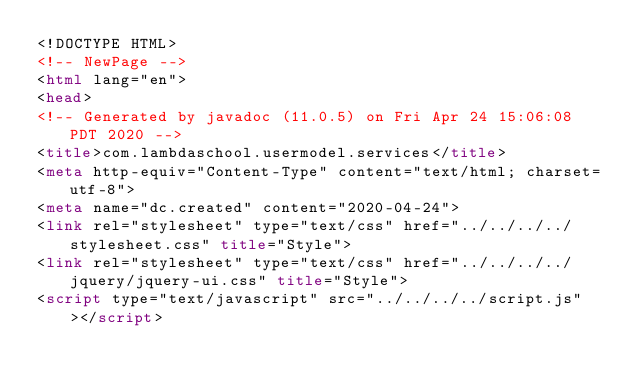Convert code to text. <code><loc_0><loc_0><loc_500><loc_500><_HTML_><!DOCTYPE HTML>
<!-- NewPage -->
<html lang="en">
<head>
<!-- Generated by javadoc (11.0.5) on Fri Apr 24 15:06:08 PDT 2020 -->
<title>com.lambdaschool.usermodel.services</title>
<meta http-equiv="Content-Type" content="text/html; charset=utf-8">
<meta name="dc.created" content="2020-04-24">
<link rel="stylesheet" type="text/css" href="../../../../stylesheet.css" title="Style">
<link rel="stylesheet" type="text/css" href="../../../../jquery/jquery-ui.css" title="Style">
<script type="text/javascript" src="../../../../script.js"></script></code> 